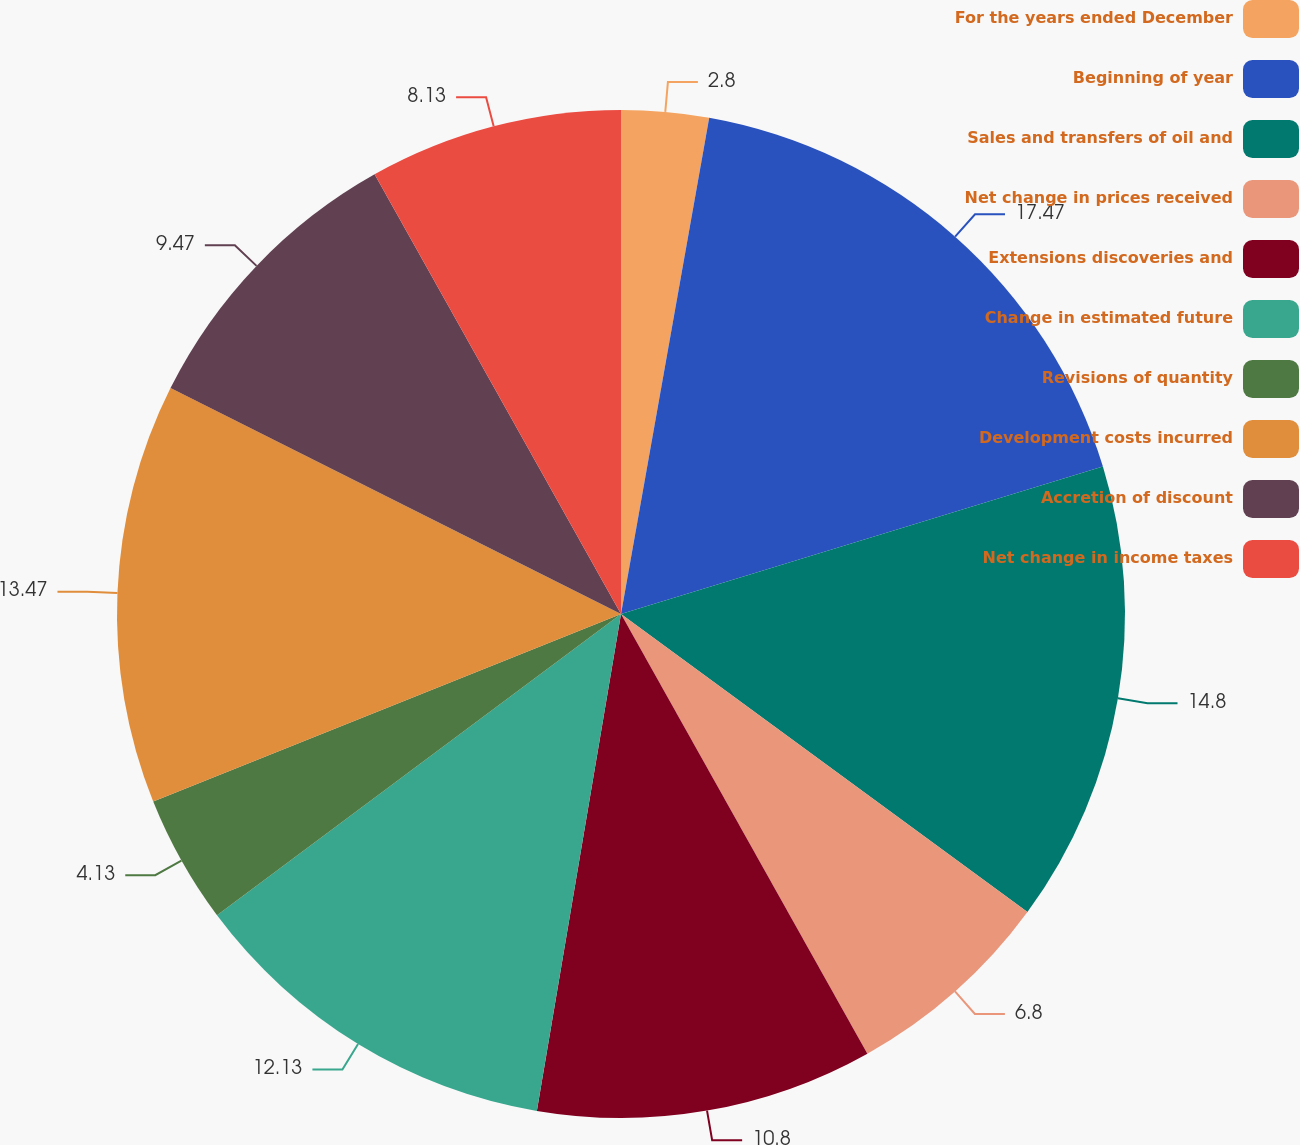Convert chart. <chart><loc_0><loc_0><loc_500><loc_500><pie_chart><fcel>For the years ended December<fcel>Beginning of year<fcel>Sales and transfers of oil and<fcel>Net change in prices received<fcel>Extensions discoveries and<fcel>Change in estimated future<fcel>Revisions of quantity<fcel>Development costs incurred<fcel>Accretion of discount<fcel>Net change in income taxes<nl><fcel>2.8%<fcel>17.47%<fcel>14.8%<fcel>6.8%<fcel>10.8%<fcel>12.13%<fcel>4.13%<fcel>13.47%<fcel>9.47%<fcel>8.13%<nl></chart> 